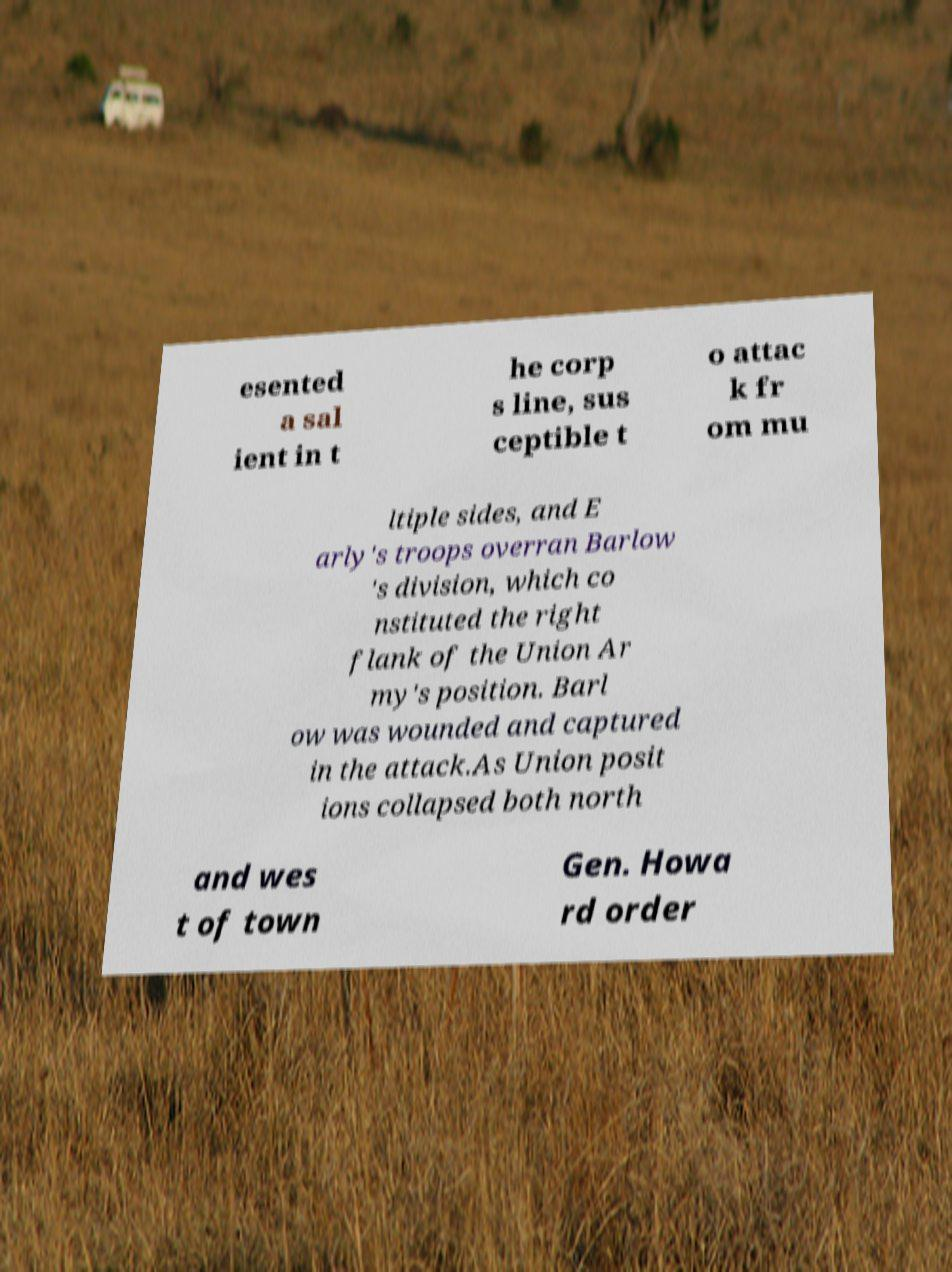Could you assist in decoding the text presented in this image and type it out clearly? esented a sal ient in t he corp s line, sus ceptible t o attac k fr om mu ltiple sides, and E arly's troops overran Barlow 's division, which co nstituted the right flank of the Union Ar my's position. Barl ow was wounded and captured in the attack.As Union posit ions collapsed both north and wes t of town Gen. Howa rd order 